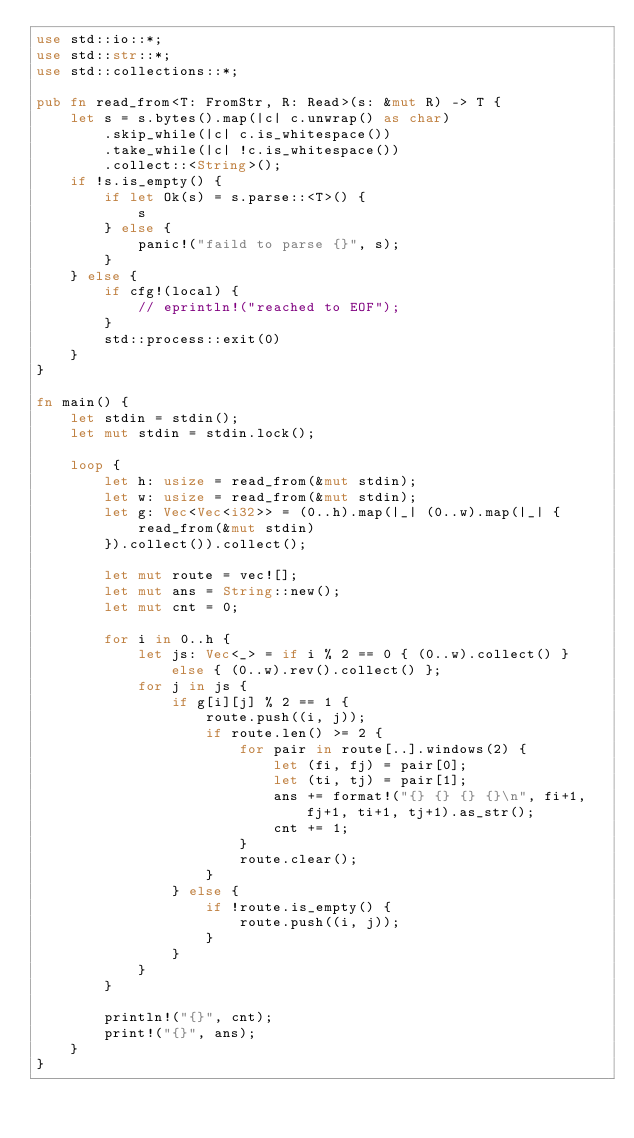Convert code to text. <code><loc_0><loc_0><loc_500><loc_500><_Rust_>use std::io::*;
use std::str::*;
use std::collections::*;

pub fn read_from<T: FromStr, R: Read>(s: &mut R) -> T {
    let s = s.bytes().map(|c| c.unwrap() as char)
        .skip_while(|c| c.is_whitespace())
        .take_while(|c| !c.is_whitespace())
        .collect::<String>();
    if !s.is_empty() {
        if let Ok(s) = s.parse::<T>() {
            s
        } else {
            panic!("faild to parse {}", s);
        }
    } else {
        if cfg!(local) {
            // eprintln!("reached to EOF");
        }
        std::process::exit(0)
    }
}

fn main() {
    let stdin = stdin();
    let mut stdin = stdin.lock();

    loop {
        let h: usize = read_from(&mut stdin);
        let w: usize = read_from(&mut stdin);
        let g: Vec<Vec<i32>> = (0..h).map(|_| (0..w).map(|_| {
            read_from(&mut stdin)
        }).collect()).collect();

        let mut route = vec![];
        let mut ans = String::new();
        let mut cnt = 0;

        for i in 0..h {
            let js: Vec<_> = if i % 2 == 0 { (0..w).collect() } else { (0..w).rev().collect() };
            for j in js {
                if g[i][j] % 2 == 1 {
                    route.push((i, j));
                    if route.len() >= 2 {
                        for pair in route[..].windows(2) {
                            let (fi, fj) = pair[0];
                            let (ti, tj) = pair[1];
                            ans += format!("{} {} {} {}\n", fi+1, fj+1, ti+1, tj+1).as_str();
                            cnt += 1;
                        }
                        route.clear();
                    }
                } else {
                    if !route.is_empty() {
                        route.push((i, j));
                    }
                }
            }
        }

        println!("{}", cnt);
        print!("{}", ans);
    }
}
</code> 